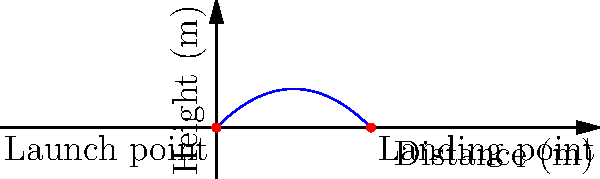In an SEO strategy to improve user engagement, you're analyzing the trajectory of user attention on a website, which follows a pattern similar to a projectile's path. Given a projectile launched at a 45-degree angle with an initial velocity of 50 m/s, what is the total horizontal distance traveled before it lands, assuming no air resistance? To solve this problem, we'll use the equations of motion for a projectile:

1) The time of flight for a projectile launched at an angle $\theta$ with initial velocity $v_0$ is given by:
   $$t_{flight} = \frac{2v_0\sin\theta}{g}$$

2) The horizontal distance traveled is given by:
   $$d = v_0\cos\theta \cdot t_{flight}$$

3) Given:
   - Initial velocity, $v_0 = 50$ m/s
   - Angle, $\theta = 45°$ (or $\pi/4$ radians)
   - Acceleration due to gravity, $g = 9.8$ m/s²

4) Calculate the time of flight:
   $$t_{flight} = \frac{2 \cdot 50 \cdot \sin(45°)}{9.8} = \frac{2 \cdot 50 \cdot \frac{\sqrt{2}}{2}}{9.8} \approx 7.22 \text{ s}$$

5) Calculate the horizontal distance:
   $$d = 50 \cdot \cos(45°) \cdot 7.22 = 50 \cdot \frac{\sqrt{2}}{2} \cdot 7.22 \approx 255 \text{ m}$$

Therefore, the total horizontal distance traveled by the projectile is approximately 255 meters.
Answer: 255 meters 